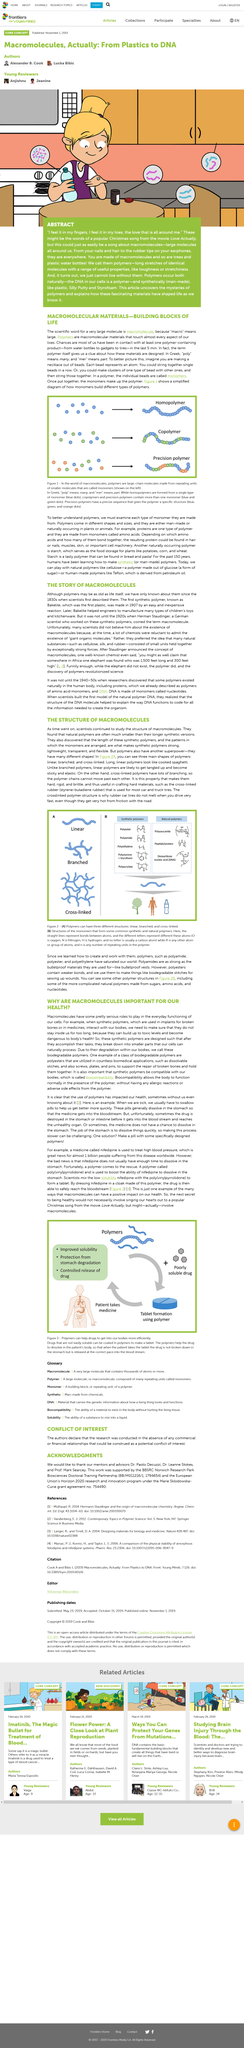Draw attention to some important aspects in this diagram. Macromolecules can have three different structures: linear, branched, and cross-linked. Linear macromolecules consist of a long chain of identical subunits, while branched macromolecules have a main chain with one or more side chains. Cross-linked macromolecules are formed by the covalent bonding of two or more chains. A macromolecule is a scientific term for a very large molecule. It is made up of many smaller units, or monomers, that are linked together to form a complex structure. Macromolecules are essential to the function of all living organisms, and they play a critical role in many biological processes, such as energy production, gene regulation, and cell communication. Examples of macromolecules include DNA, RNA, proteins, and carbohydrates. The polymer and the poorly soluble drug combine to form a medicine in the form of a tablet. The monomers that make up the polymer are composed of various types of molecules. Biodegradable polymers are the same as synthetic polymers. 